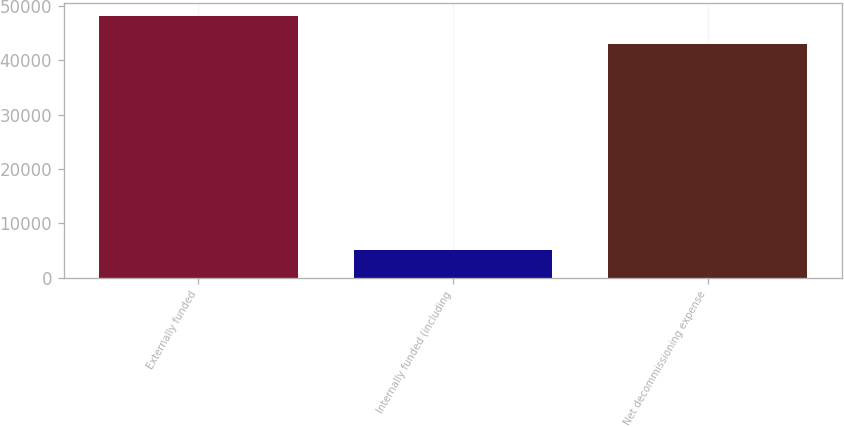Convert chart to OTSL. <chart><loc_0><loc_0><loc_500><loc_500><bar_chart><fcel>Externally funded<fcel>Internally funded (including<fcel>Net decommissioning expense<nl><fcel>48069<fcel>5046<fcel>43023<nl></chart> 